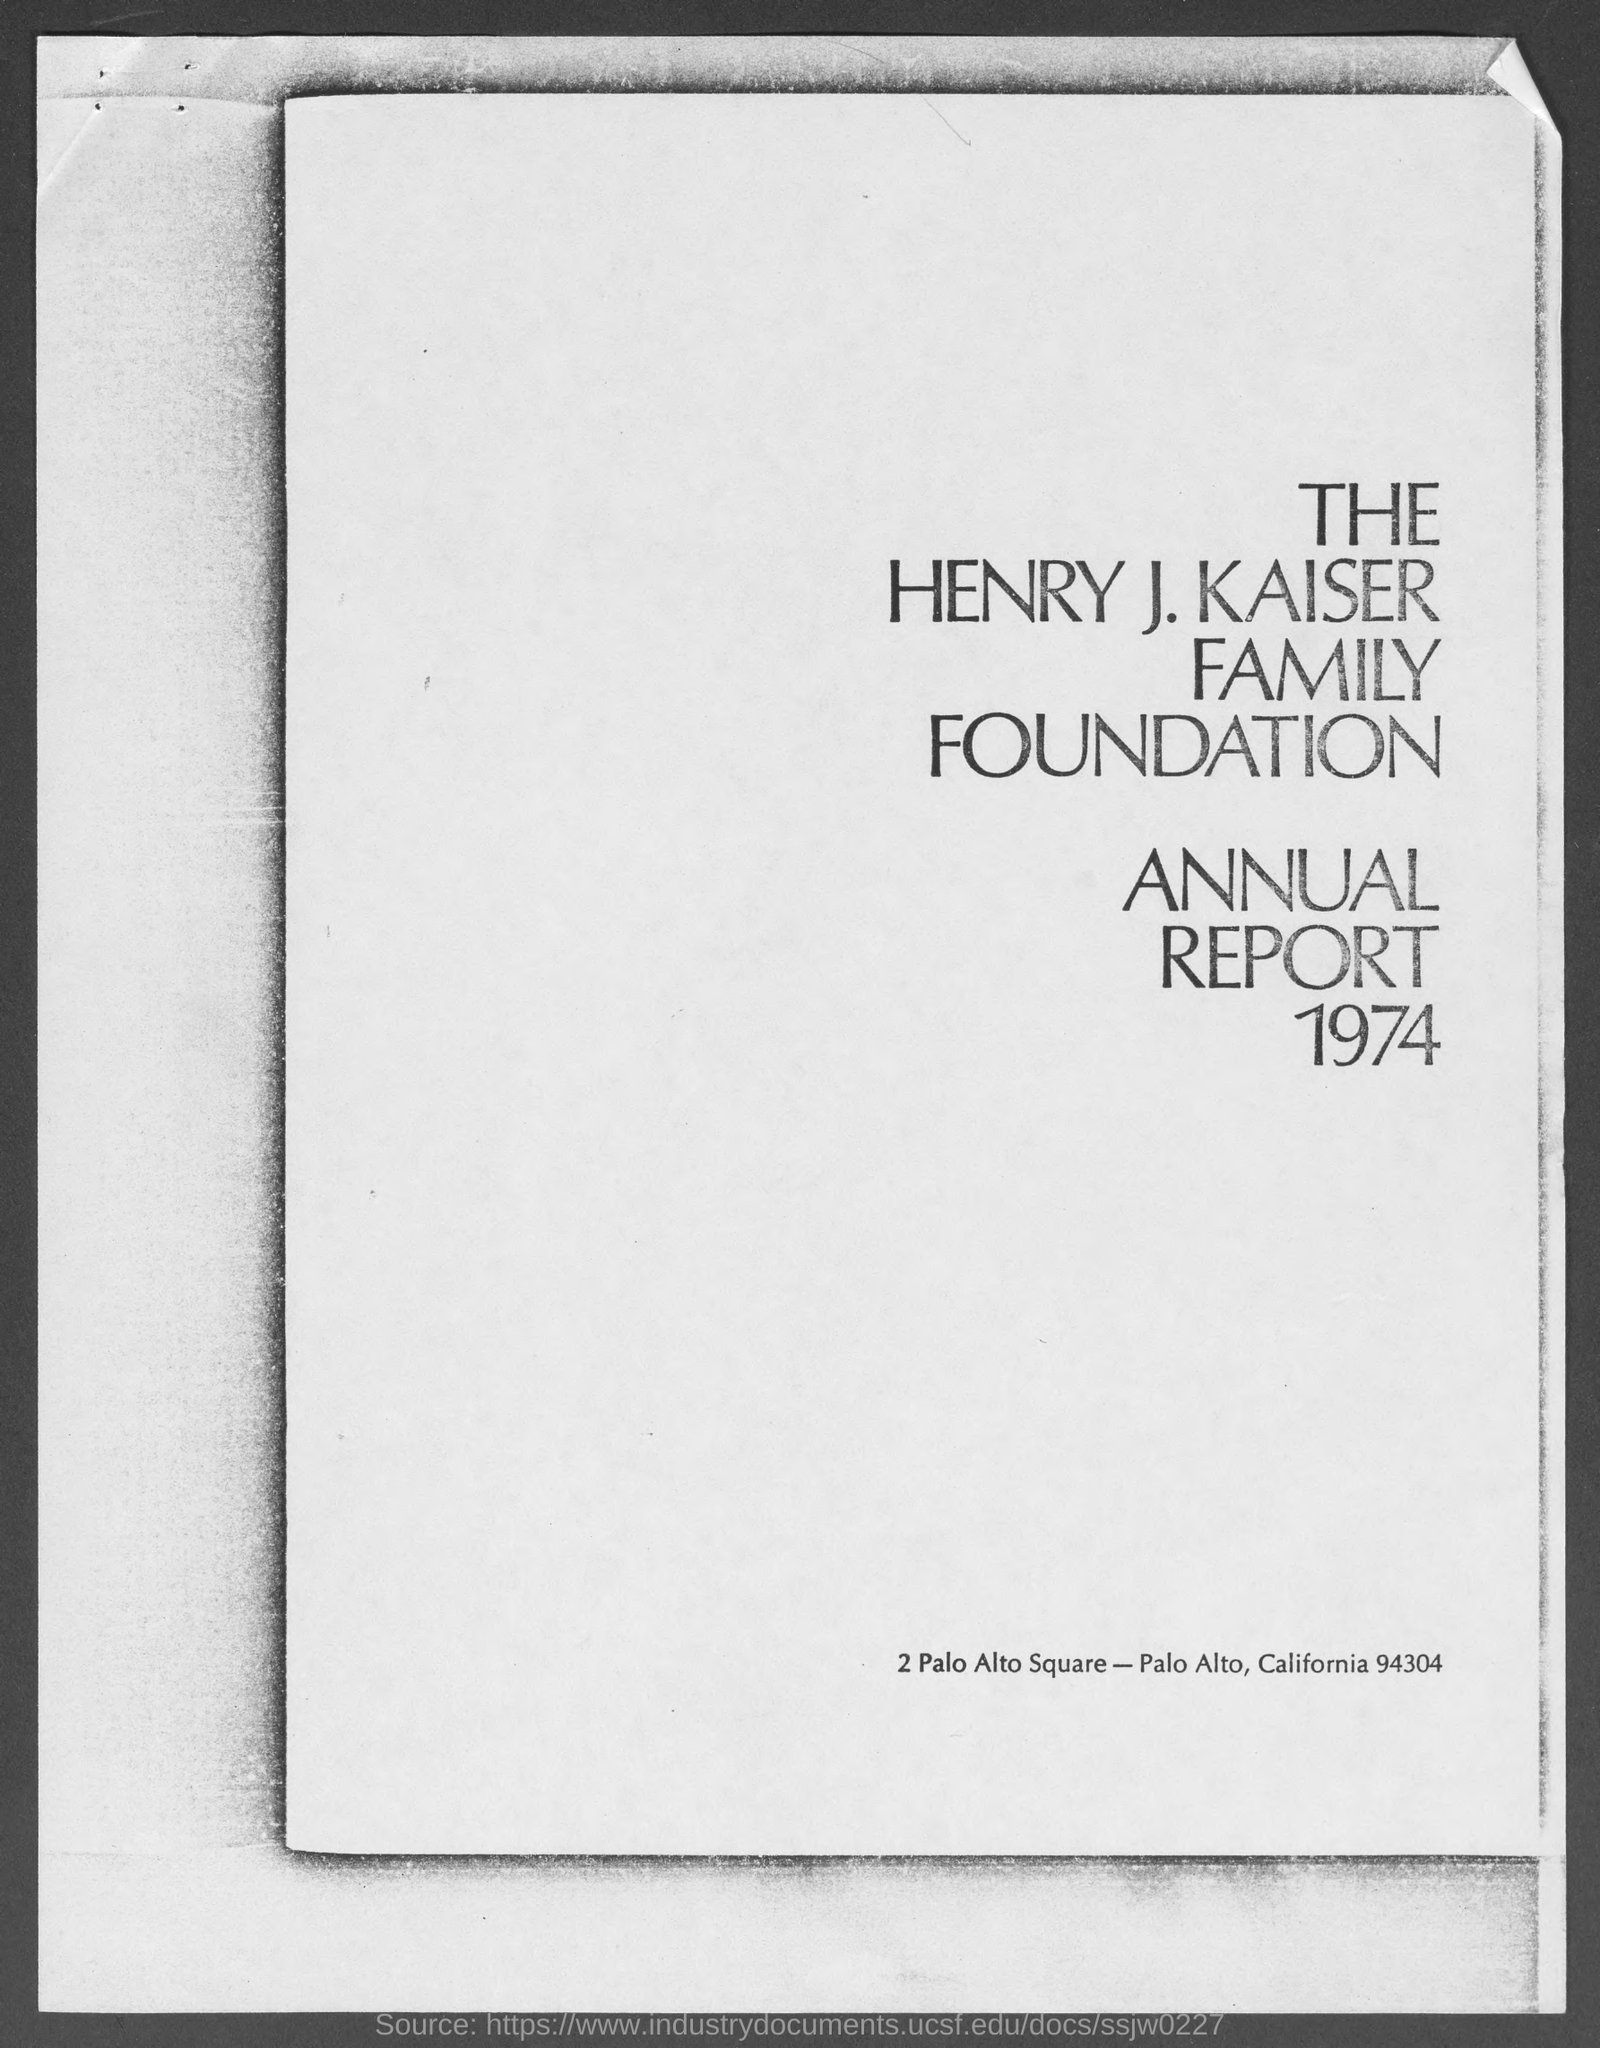What is the street address of the henry j. kaiser family foundation
Your answer should be very brief. 2 Palo Alto Square. What is the year written below annual report ?
Your answer should be compact. 1974. 